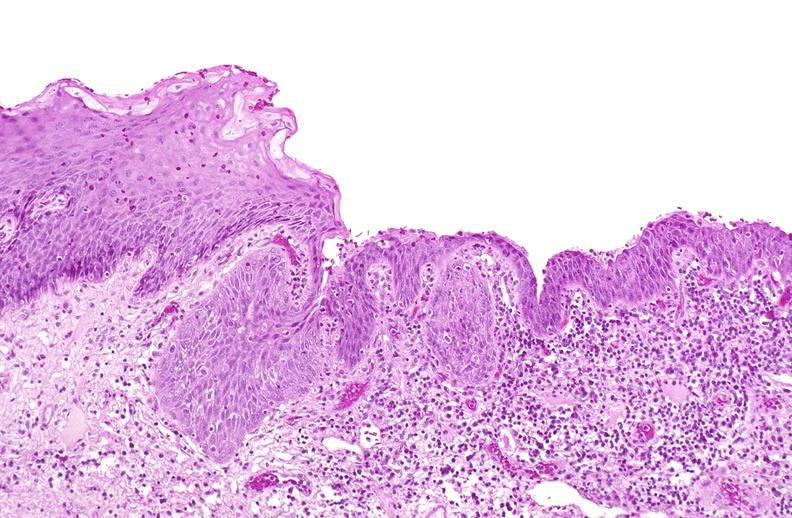does this image show squamous metaplasia, renal pelvis due to nephrolithiasis?
Answer the question using a single word or phrase. Yes 